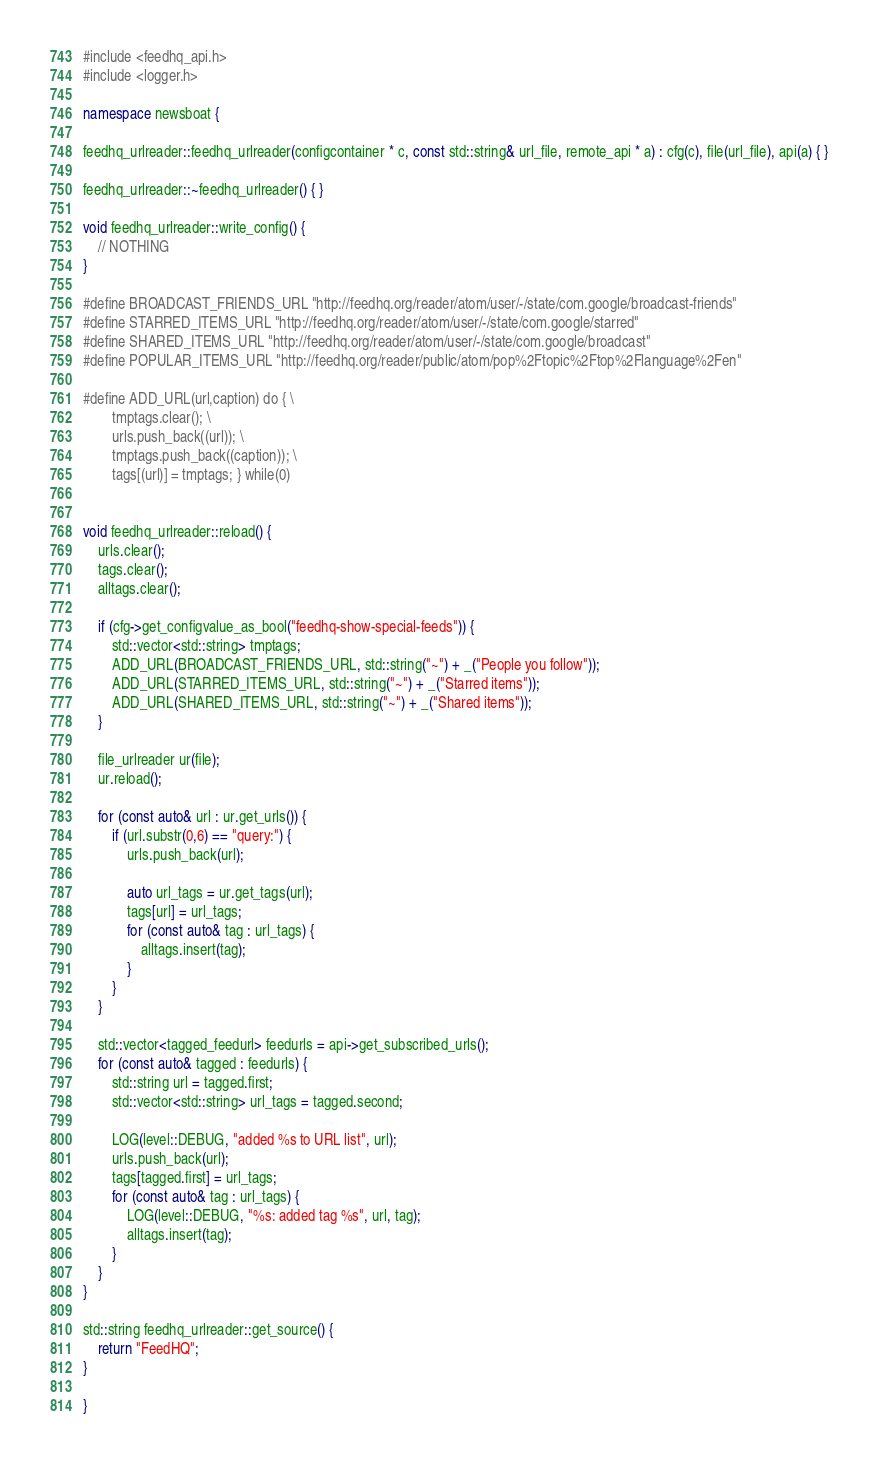Convert code to text. <code><loc_0><loc_0><loc_500><loc_500><_C++_>#include <feedhq_api.h>
#include <logger.h>

namespace newsboat {

feedhq_urlreader::feedhq_urlreader(configcontainer * c, const std::string& url_file, remote_api * a) : cfg(c), file(url_file), api(a) { }

feedhq_urlreader::~feedhq_urlreader() { }

void feedhq_urlreader::write_config() {
	// NOTHING
}

#define BROADCAST_FRIENDS_URL "http://feedhq.org/reader/atom/user/-/state/com.google/broadcast-friends"
#define STARRED_ITEMS_URL "http://feedhq.org/reader/atom/user/-/state/com.google/starred"
#define SHARED_ITEMS_URL "http://feedhq.org/reader/atom/user/-/state/com.google/broadcast"
#define POPULAR_ITEMS_URL "http://feedhq.org/reader/public/atom/pop%2Ftopic%2Ftop%2Flanguage%2Fen"

#define ADD_URL(url,caption) do { \
		tmptags.clear(); \
		urls.push_back((url)); \
		tmptags.push_back((caption)); \
		tags[(url)] = tmptags; } while(0)


void feedhq_urlreader::reload() {
	urls.clear();
	tags.clear();
	alltags.clear();

	if (cfg->get_configvalue_as_bool("feedhq-show-special-feeds")) {
		std::vector<std::string> tmptags;
		ADD_URL(BROADCAST_FRIENDS_URL, std::string("~") + _("People you follow"));
		ADD_URL(STARRED_ITEMS_URL, std::string("~") + _("Starred items"));
		ADD_URL(SHARED_ITEMS_URL, std::string("~") + _("Shared items"));
	}

	file_urlreader ur(file);
	ur.reload();

	for (const auto& url : ur.get_urls()) {
		if (url.substr(0,6) == "query:") {
			urls.push_back(url);

			auto url_tags = ur.get_tags(url);
			tags[url] = url_tags;
			for (const auto& tag : url_tags) {
				alltags.insert(tag);
			}
		}
	}

	std::vector<tagged_feedurl> feedurls = api->get_subscribed_urls();
	for (const auto& tagged : feedurls) {
		std::string url = tagged.first;
		std::vector<std::string> url_tags = tagged.second;

		LOG(level::DEBUG, "added %s to URL list", url);
		urls.push_back(url);
		tags[tagged.first] = url_tags;
		for (const auto& tag : url_tags) {
			LOG(level::DEBUG, "%s: added tag %s", url, tag);
			alltags.insert(tag);
		}
	}
}

std::string feedhq_urlreader::get_source() {
	return "FeedHQ";
}

}
</code> 